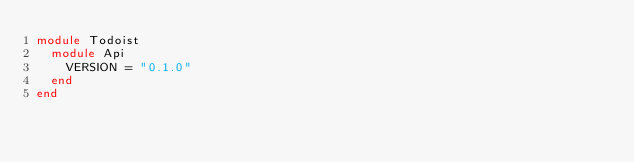<code> <loc_0><loc_0><loc_500><loc_500><_Ruby_>module Todoist
  module Api
    VERSION = "0.1.0"
  end
end
</code> 